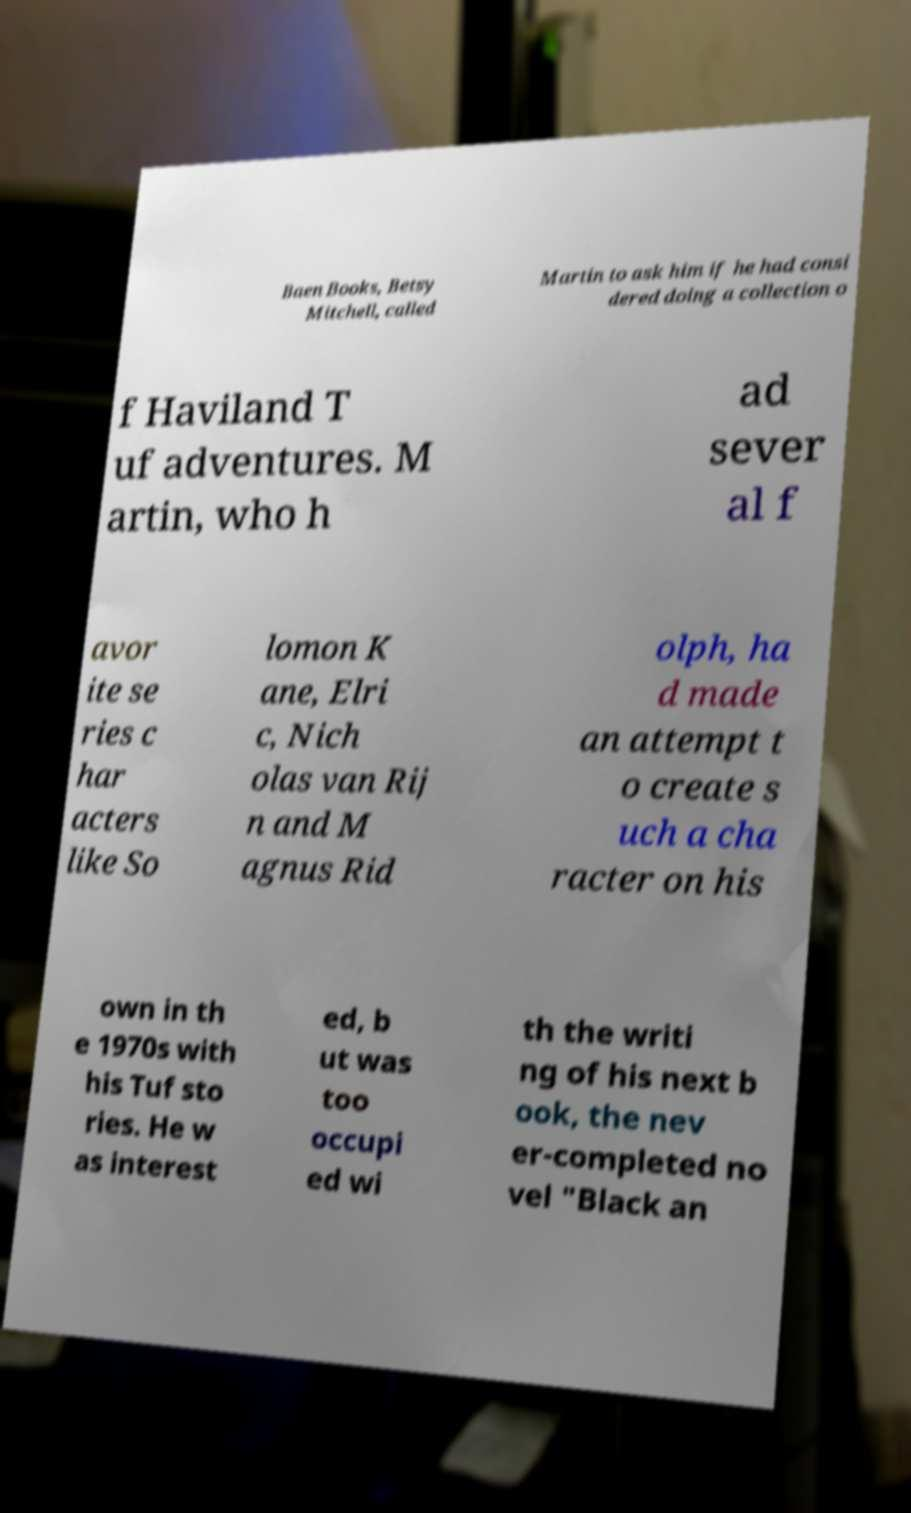I need the written content from this picture converted into text. Can you do that? Baen Books, Betsy Mitchell, called Martin to ask him if he had consi dered doing a collection o f Haviland T uf adventures. M artin, who h ad sever al f avor ite se ries c har acters like So lomon K ane, Elri c, Nich olas van Rij n and M agnus Rid olph, ha d made an attempt t o create s uch a cha racter on his own in th e 1970s with his Tuf sto ries. He w as interest ed, b ut was too occupi ed wi th the writi ng of his next b ook, the nev er-completed no vel "Black an 